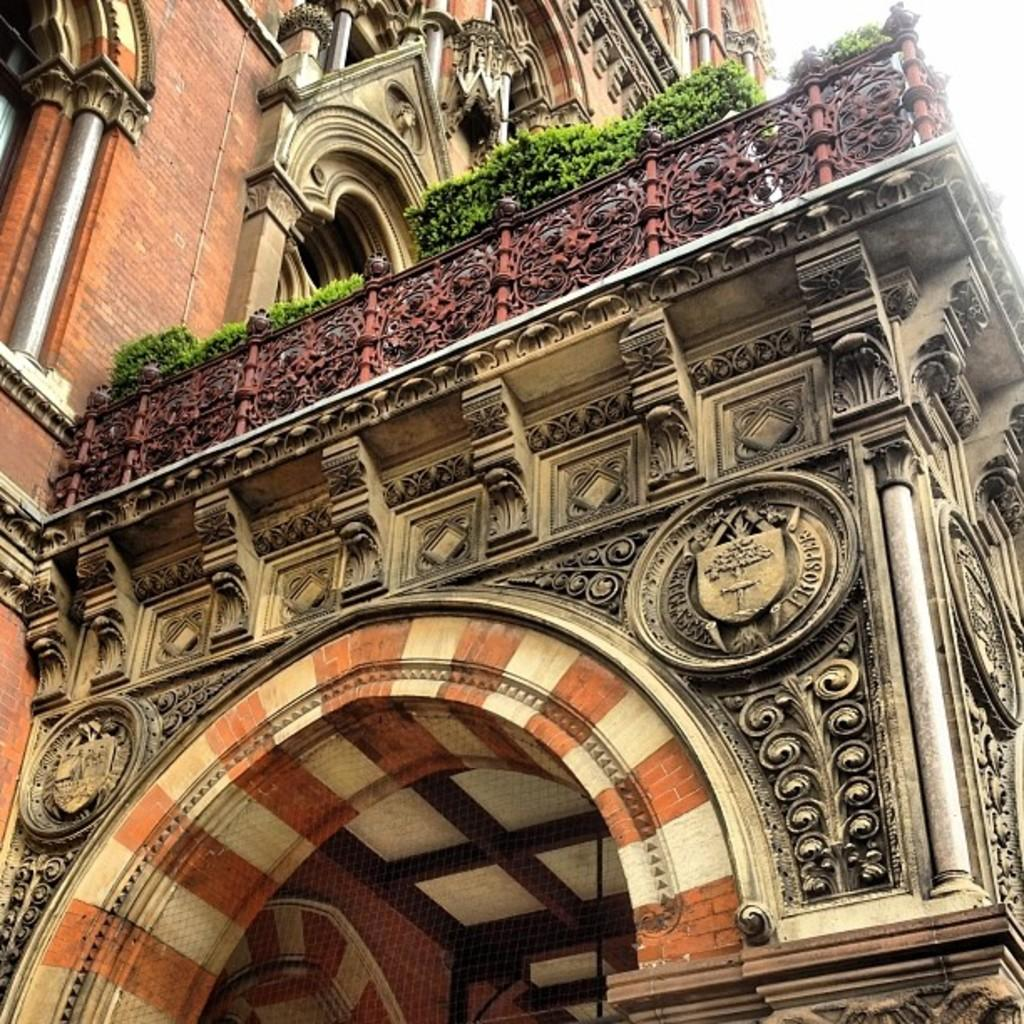What is the main structure in the picture? There is a building in the picture. What is covering the building? There are plants on the building. What can be seen on the walls of the building? There are designs on the walls of the building. How many feet are visible on the building in the image? There are no feet visible on the building in the image. What type of art is displayed on the walls of the building? The designs on the walls of the building are not specified as a particular type of art in the image. 